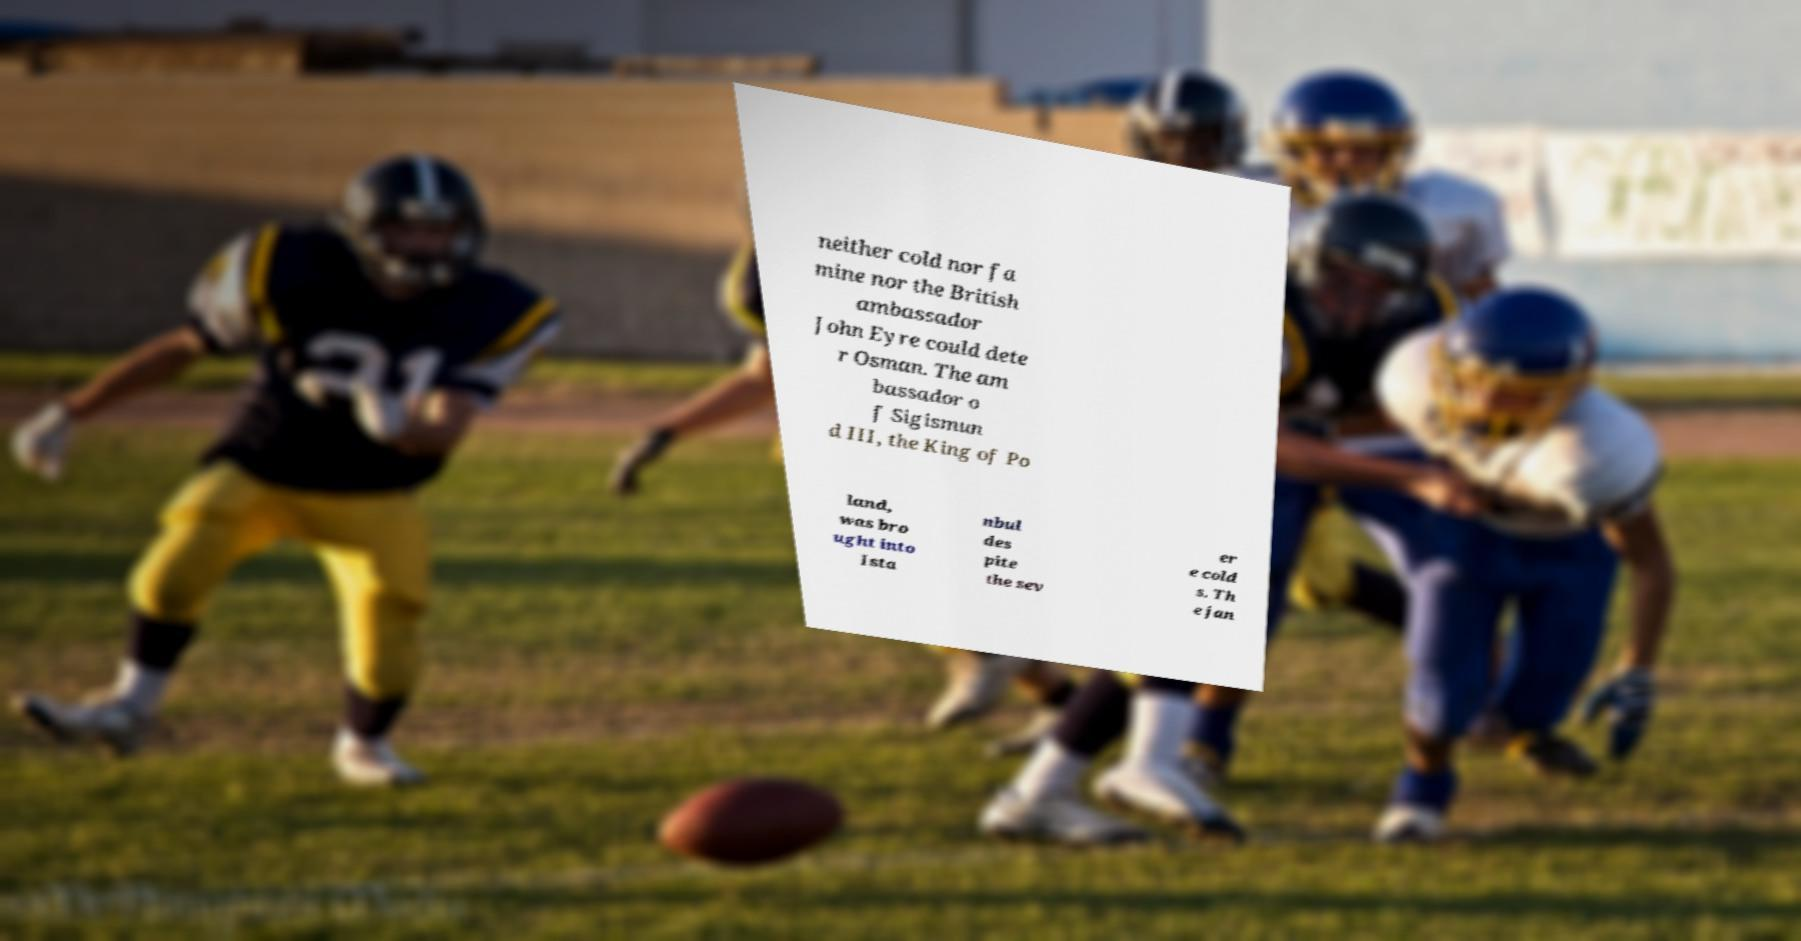Please read and relay the text visible in this image. What does it say? neither cold nor fa mine nor the British ambassador John Eyre could dete r Osman. The am bassador o f Sigismun d III, the King of Po land, was bro ught into Ista nbul des pite the sev er e cold s. Th e jan 